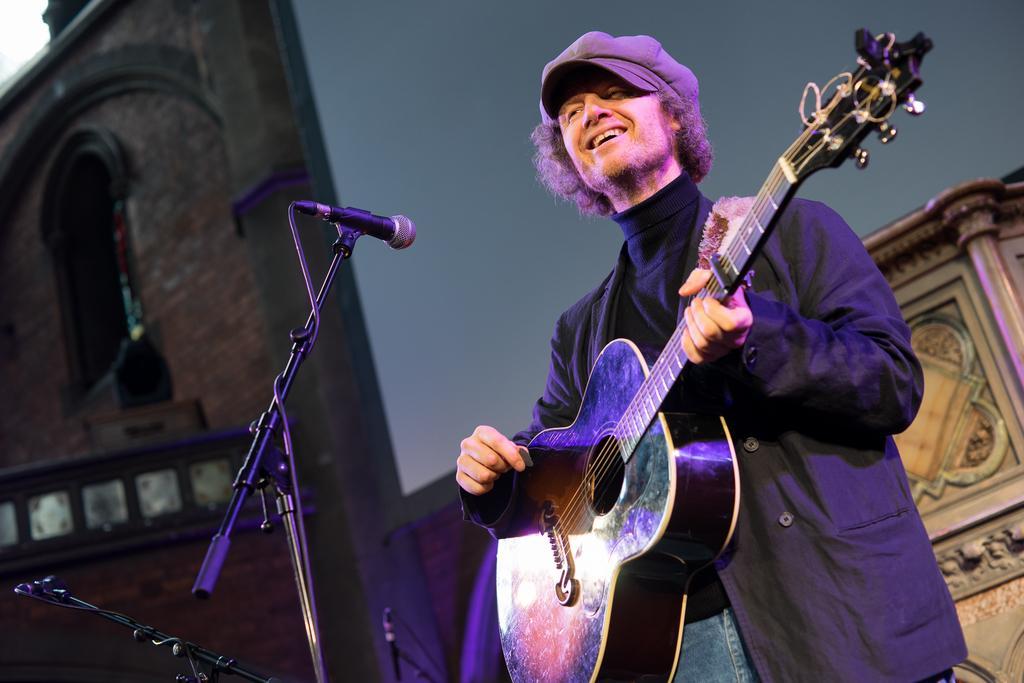Describe this image in one or two sentences. Here we can see a man standing and smiling, and he is holding the guitar in his hands, and in front here is the microphone. 